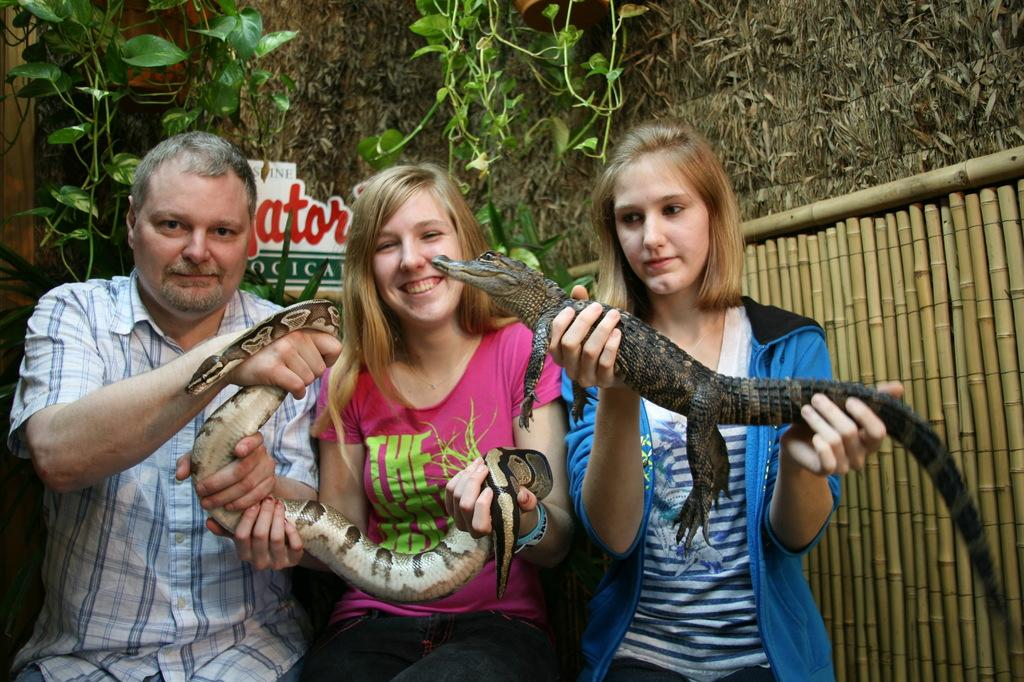How many people are in the image? There are three persons in the image. What are the persons doing in the image? The persons are catching reptiles in their hands. What can be seen in the background of the image? There are trees and a wall in the background of the image. What type of coal can be seen in the image? There is no coal present in the image. Can you describe the flock of birds in the image? There are no birds or flocks present in the image. 